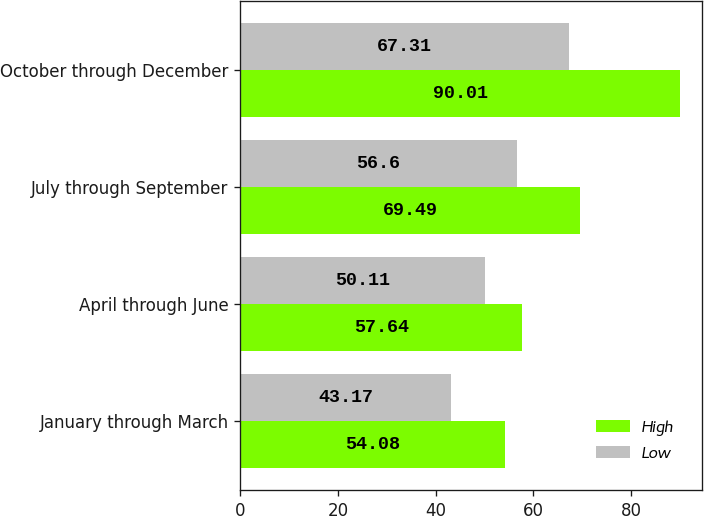Convert chart. <chart><loc_0><loc_0><loc_500><loc_500><stacked_bar_chart><ecel><fcel>January through March<fcel>April through June<fcel>July through September<fcel>October through December<nl><fcel>High<fcel>54.08<fcel>57.64<fcel>69.49<fcel>90.01<nl><fcel>Low<fcel>43.17<fcel>50.11<fcel>56.6<fcel>67.31<nl></chart> 